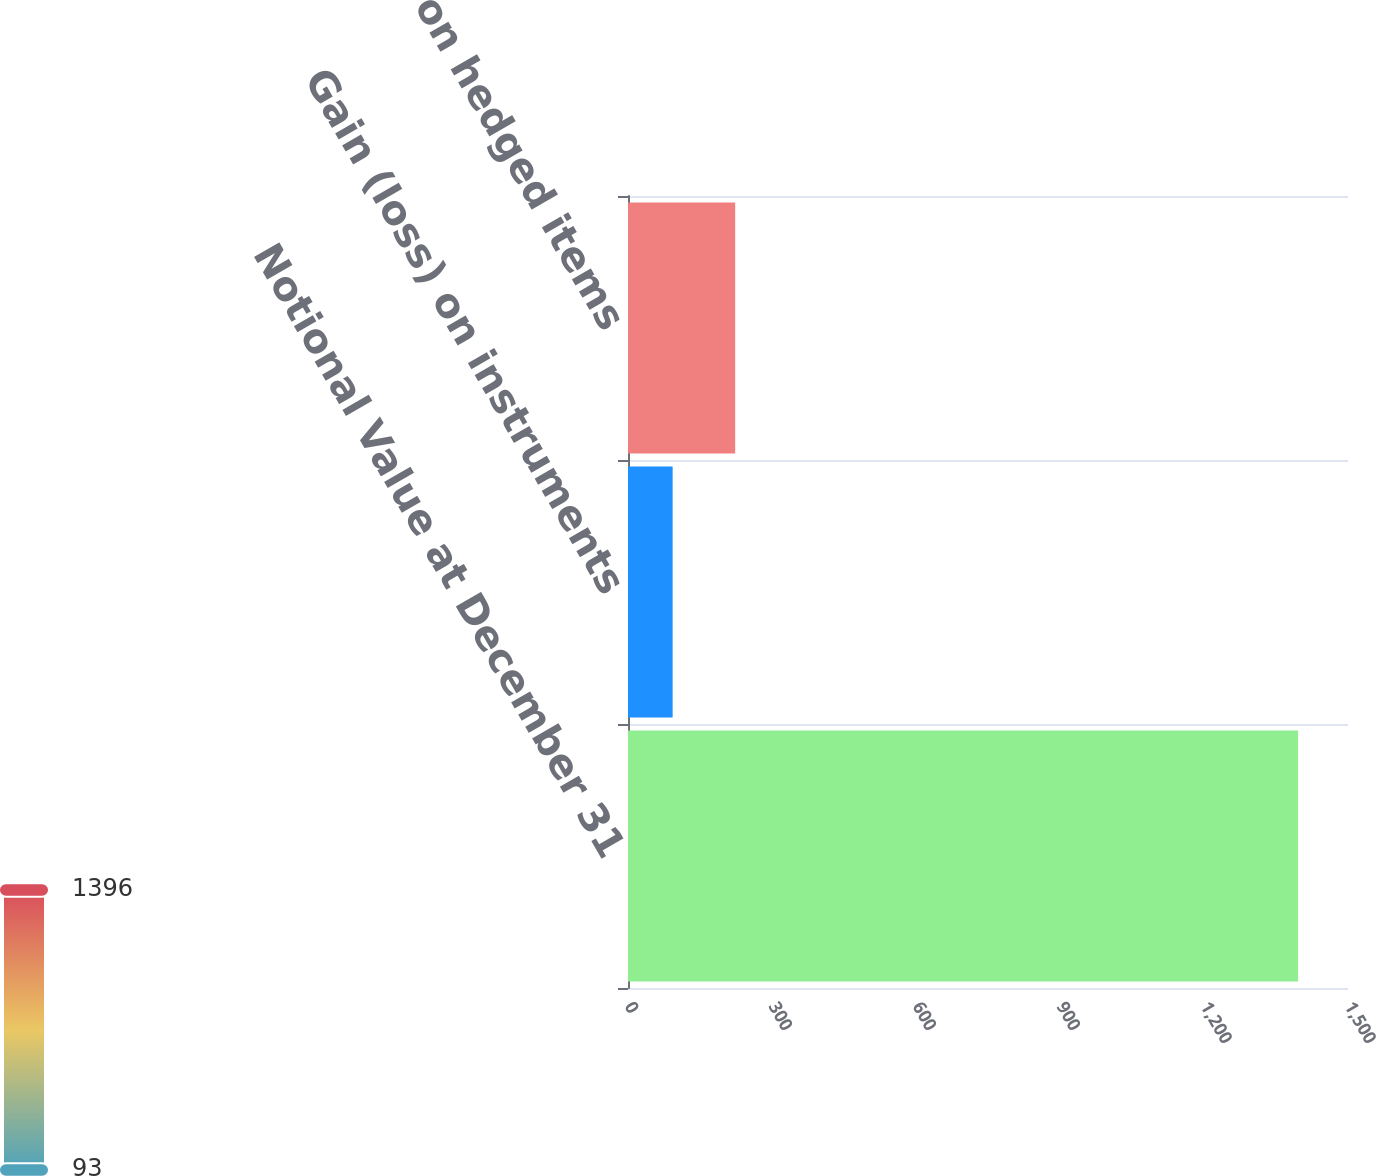<chart> <loc_0><loc_0><loc_500><loc_500><bar_chart><fcel>Notional Value at December 31<fcel>Gain (loss) on instruments<fcel>Gain (loss) on hedged items<nl><fcel>1396<fcel>93<fcel>223.3<nl></chart> 